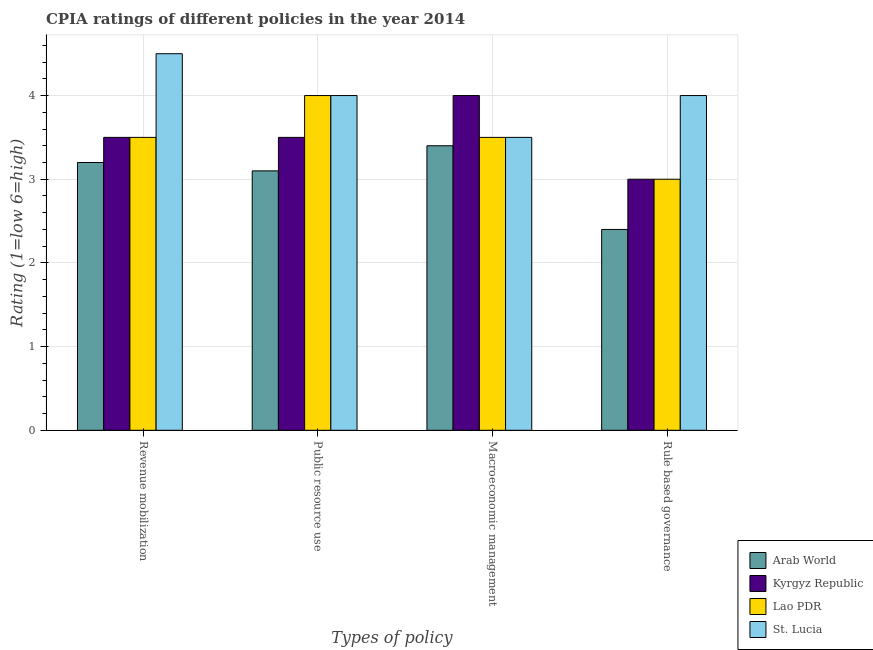Are the number of bars per tick equal to the number of legend labels?
Provide a succinct answer. Yes. How many bars are there on the 2nd tick from the left?
Provide a succinct answer. 4. What is the label of the 1st group of bars from the left?
Give a very brief answer. Revenue mobilization. What is the cpia rating of rule based governance in Kyrgyz Republic?
Keep it short and to the point. 3. Across all countries, what is the minimum cpia rating of public resource use?
Make the answer very short. 3.1. In which country was the cpia rating of macroeconomic management maximum?
Your answer should be compact. Kyrgyz Republic. In which country was the cpia rating of revenue mobilization minimum?
Make the answer very short. Arab World. What is the total cpia rating of macroeconomic management in the graph?
Provide a short and direct response. 14.4. What is the difference between the cpia rating of revenue mobilization in St. Lucia and that in Arab World?
Offer a terse response. 1.3. What is the difference between the cpia rating of public resource use in St. Lucia and the cpia rating of rule based governance in Arab World?
Provide a short and direct response. 1.6. What is the average cpia rating of public resource use per country?
Your answer should be very brief. 3.65. What is the difference between the cpia rating of public resource use and cpia rating of revenue mobilization in St. Lucia?
Make the answer very short. -0.5. What is the ratio of the cpia rating of public resource use in Kyrgyz Republic to that in St. Lucia?
Give a very brief answer. 0.88. Is the cpia rating of rule based governance in Kyrgyz Republic less than that in Arab World?
Give a very brief answer. No. What is the difference between the highest and the second highest cpia rating of revenue mobilization?
Your answer should be compact. 1. What is the difference between the highest and the lowest cpia rating of public resource use?
Give a very brief answer. 0.9. Is the sum of the cpia rating of revenue mobilization in St. Lucia and Arab World greater than the maximum cpia rating of rule based governance across all countries?
Offer a very short reply. Yes. Is it the case that in every country, the sum of the cpia rating of rule based governance and cpia rating of revenue mobilization is greater than the sum of cpia rating of public resource use and cpia rating of macroeconomic management?
Ensure brevity in your answer.  No. What does the 2nd bar from the left in Rule based governance represents?
Your answer should be very brief. Kyrgyz Republic. What does the 2nd bar from the right in Revenue mobilization represents?
Your answer should be very brief. Lao PDR. Is it the case that in every country, the sum of the cpia rating of revenue mobilization and cpia rating of public resource use is greater than the cpia rating of macroeconomic management?
Ensure brevity in your answer.  Yes. How many bars are there?
Offer a terse response. 16. Are all the bars in the graph horizontal?
Keep it short and to the point. No. How many countries are there in the graph?
Offer a very short reply. 4. Are the values on the major ticks of Y-axis written in scientific E-notation?
Your response must be concise. No. Does the graph contain any zero values?
Provide a short and direct response. No. Does the graph contain grids?
Your response must be concise. Yes. Where does the legend appear in the graph?
Keep it short and to the point. Bottom right. What is the title of the graph?
Give a very brief answer. CPIA ratings of different policies in the year 2014. What is the label or title of the X-axis?
Your response must be concise. Types of policy. What is the Rating (1=low 6=high) in Arab World in Revenue mobilization?
Ensure brevity in your answer.  3.2. What is the Rating (1=low 6=high) of Lao PDR in Revenue mobilization?
Give a very brief answer. 3.5. What is the Rating (1=low 6=high) in Arab World in Public resource use?
Make the answer very short. 3.1. What is the Rating (1=low 6=high) of Kyrgyz Republic in Public resource use?
Ensure brevity in your answer.  3.5. What is the Rating (1=low 6=high) in Lao PDR in Macroeconomic management?
Make the answer very short. 3.5. What is the Rating (1=low 6=high) in Kyrgyz Republic in Rule based governance?
Ensure brevity in your answer.  3. What is the Rating (1=low 6=high) of St. Lucia in Rule based governance?
Your answer should be very brief. 4. Across all Types of policy, what is the maximum Rating (1=low 6=high) of Arab World?
Your answer should be compact. 3.4. Across all Types of policy, what is the maximum Rating (1=low 6=high) of Kyrgyz Republic?
Make the answer very short. 4. Across all Types of policy, what is the maximum Rating (1=low 6=high) in St. Lucia?
Provide a succinct answer. 4.5. Across all Types of policy, what is the minimum Rating (1=low 6=high) of Arab World?
Provide a succinct answer. 2.4. What is the total Rating (1=low 6=high) of Lao PDR in the graph?
Provide a short and direct response. 14. What is the difference between the Rating (1=low 6=high) in Kyrgyz Republic in Revenue mobilization and that in Public resource use?
Give a very brief answer. 0. What is the difference between the Rating (1=low 6=high) of Lao PDR in Revenue mobilization and that in Macroeconomic management?
Keep it short and to the point. 0. What is the difference between the Rating (1=low 6=high) of Kyrgyz Republic in Public resource use and that in Macroeconomic management?
Offer a very short reply. -0.5. What is the difference between the Rating (1=low 6=high) of Arab World in Public resource use and that in Rule based governance?
Give a very brief answer. 0.7. What is the difference between the Rating (1=low 6=high) of St. Lucia in Public resource use and that in Rule based governance?
Provide a succinct answer. 0. What is the difference between the Rating (1=low 6=high) of Kyrgyz Republic in Revenue mobilization and the Rating (1=low 6=high) of Lao PDR in Public resource use?
Offer a terse response. -0.5. What is the difference between the Rating (1=low 6=high) in Arab World in Revenue mobilization and the Rating (1=low 6=high) in Kyrgyz Republic in Macroeconomic management?
Keep it short and to the point. -0.8. What is the difference between the Rating (1=low 6=high) in Arab World in Revenue mobilization and the Rating (1=low 6=high) in Lao PDR in Macroeconomic management?
Your answer should be very brief. -0.3. What is the difference between the Rating (1=low 6=high) of Arab World in Revenue mobilization and the Rating (1=low 6=high) of St. Lucia in Rule based governance?
Your answer should be compact. -0.8. What is the difference between the Rating (1=low 6=high) of Kyrgyz Republic in Revenue mobilization and the Rating (1=low 6=high) of Lao PDR in Rule based governance?
Provide a succinct answer. 0.5. What is the difference between the Rating (1=low 6=high) of Kyrgyz Republic in Revenue mobilization and the Rating (1=low 6=high) of St. Lucia in Rule based governance?
Give a very brief answer. -0.5. What is the difference between the Rating (1=low 6=high) in Lao PDR in Revenue mobilization and the Rating (1=low 6=high) in St. Lucia in Rule based governance?
Your answer should be very brief. -0.5. What is the difference between the Rating (1=low 6=high) of Arab World in Public resource use and the Rating (1=low 6=high) of Lao PDR in Macroeconomic management?
Your answer should be compact. -0.4. What is the difference between the Rating (1=low 6=high) in Arab World in Public resource use and the Rating (1=low 6=high) in St. Lucia in Macroeconomic management?
Offer a very short reply. -0.4. What is the difference between the Rating (1=low 6=high) in Kyrgyz Republic in Public resource use and the Rating (1=low 6=high) in Lao PDR in Macroeconomic management?
Give a very brief answer. 0. What is the difference between the Rating (1=low 6=high) in Kyrgyz Republic in Public resource use and the Rating (1=low 6=high) in St. Lucia in Macroeconomic management?
Offer a terse response. 0. What is the difference between the Rating (1=low 6=high) of Arab World in Public resource use and the Rating (1=low 6=high) of Kyrgyz Republic in Rule based governance?
Provide a succinct answer. 0.1. What is the difference between the Rating (1=low 6=high) of Arab World in Public resource use and the Rating (1=low 6=high) of Lao PDR in Rule based governance?
Make the answer very short. 0.1. What is the difference between the Rating (1=low 6=high) in Arab World in Public resource use and the Rating (1=low 6=high) in St. Lucia in Rule based governance?
Keep it short and to the point. -0.9. What is the difference between the Rating (1=low 6=high) of Lao PDR in Public resource use and the Rating (1=low 6=high) of St. Lucia in Rule based governance?
Ensure brevity in your answer.  0. What is the difference between the Rating (1=low 6=high) of Arab World in Macroeconomic management and the Rating (1=low 6=high) of Lao PDR in Rule based governance?
Give a very brief answer. 0.4. What is the difference between the Rating (1=low 6=high) of Lao PDR in Macroeconomic management and the Rating (1=low 6=high) of St. Lucia in Rule based governance?
Keep it short and to the point. -0.5. What is the average Rating (1=low 6=high) of Arab World per Types of policy?
Give a very brief answer. 3.02. What is the average Rating (1=low 6=high) in Kyrgyz Republic per Types of policy?
Provide a succinct answer. 3.5. What is the average Rating (1=low 6=high) in Lao PDR per Types of policy?
Your answer should be very brief. 3.5. What is the average Rating (1=low 6=high) of St. Lucia per Types of policy?
Your response must be concise. 4. What is the difference between the Rating (1=low 6=high) in Arab World and Rating (1=low 6=high) in Kyrgyz Republic in Revenue mobilization?
Offer a very short reply. -0.3. What is the difference between the Rating (1=low 6=high) of Arab World and Rating (1=low 6=high) of St. Lucia in Revenue mobilization?
Ensure brevity in your answer.  -1.3. What is the difference between the Rating (1=low 6=high) in Arab World and Rating (1=low 6=high) in Kyrgyz Republic in Public resource use?
Provide a succinct answer. -0.4. What is the difference between the Rating (1=low 6=high) of Kyrgyz Republic and Rating (1=low 6=high) of Lao PDR in Public resource use?
Give a very brief answer. -0.5. What is the difference between the Rating (1=low 6=high) in Arab World and Rating (1=low 6=high) in Lao PDR in Rule based governance?
Offer a very short reply. -0.6. What is the difference between the Rating (1=low 6=high) in Arab World and Rating (1=low 6=high) in St. Lucia in Rule based governance?
Your answer should be very brief. -1.6. What is the difference between the Rating (1=low 6=high) in Kyrgyz Republic and Rating (1=low 6=high) in Lao PDR in Rule based governance?
Offer a very short reply. 0. What is the difference between the Rating (1=low 6=high) in Kyrgyz Republic and Rating (1=low 6=high) in St. Lucia in Rule based governance?
Give a very brief answer. -1. What is the ratio of the Rating (1=low 6=high) of Arab World in Revenue mobilization to that in Public resource use?
Provide a short and direct response. 1.03. What is the ratio of the Rating (1=low 6=high) in Lao PDR in Revenue mobilization to that in Public resource use?
Provide a short and direct response. 0.88. What is the ratio of the Rating (1=low 6=high) in St. Lucia in Revenue mobilization to that in Public resource use?
Offer a terse response. 1.12. What is the ratio of the Rating (1=low 6=high) in Arab World in Revenue mobilization to that in Macroeconomic management?
Give a very brief answer. 0.94. What is the ratio of the Rating (1=low 6=high) of St. Lucia in Revenue mobilization to that in Macroeconomic management?
Your answer should be very brief. 1.29. What is the ratio of the Rating (1=low 6=high) of Kyrgyz Republic in Revenue mobilization to that in Rule based governance?
Ensure brevity in your answer.  1.17. What is the ratio of the Rating (1=low 6=high) in Lao PDR in Revenue mobilization to that in Rule based governance?
Your answer should be compact. 1.17. What is the ratio of the Rating (1=low 6=high) in St. Lucia in Revenue mobilization to that in Rule based governance?
Your answer should be very brief. 1.12. What is the ratio of the Rating (1=low 6=high) of Arab World in Public resource use to that in Macroeconomic management?
Give a very brief answer. 0.91. What is the ratio of the Rating (1=low 6=high) of Kyrgyz Republic in Public resource use to that in Macroeconomic management?
Keep it short and to the point. 0.88. What is the ratio of the Rating (1=low 6=high) in Lao PDR in Public resource use to that in Macroeconomic management?
Give a very brief answer. 1.14. What is the ratio of the Rating (1=low 6=high) in Arab World in Public resource use to that in Rule based governance?
Provide a succinct answer. 1.29. What is the ratio of the Rating (1=low 6=high) in Arab World in Macroeconomic management to that in Rule based governance?
Keep it short and to the point. 1.42. What is the difference between the highest and the second highest Rating (1=low 6=high) of Kyrgyz Republic?
Your answer should be compact. 0.5. What is the difference between the highest and the second highest Rating (1=low 6=high) of Lao PDR?
Keep it short and to the point. 0.5. What is the difference between the highest and the lowest Rating (1=low 6=high) in St. Lucia?
Offer a very short reply. 1. 